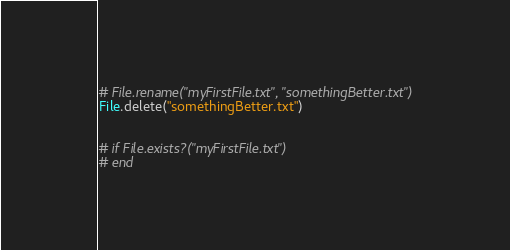Convert code to text. <code><loc_0><loc_0><loc_500><loc_500><_Ruby_># File.rename("myFirstFile.txt", "somethingBetter.txt")
File.delete("somethingBetter.txt")


# if File.exists?("myFirstFile.txt")
# end
</code> 